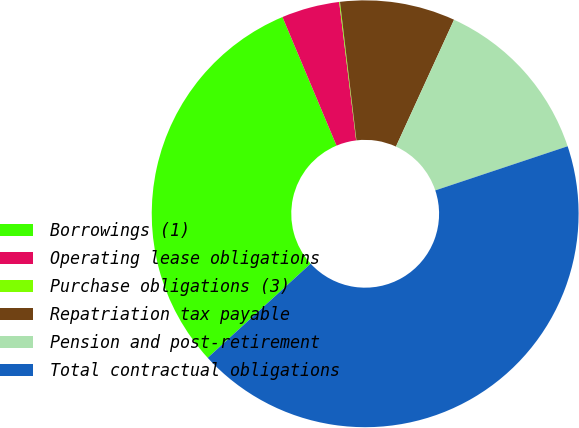Convert chart. <chart><loc_0><loc_0><loc_500><loc_500><pie_chart><fcel>Borrowings (1)<fcel>Operating lease obligations<fcel>Purchase obligations (3)<fcel>Repatriation tax payable<fcel>Pension and post-retirement<fcel>Total contractual obligations<nl><fcel>30.46%<fcel>4.39%<fcel>0.06%<fcel>8.72%<fcel>13.04%<fcel>43.33%<nl></chart> 